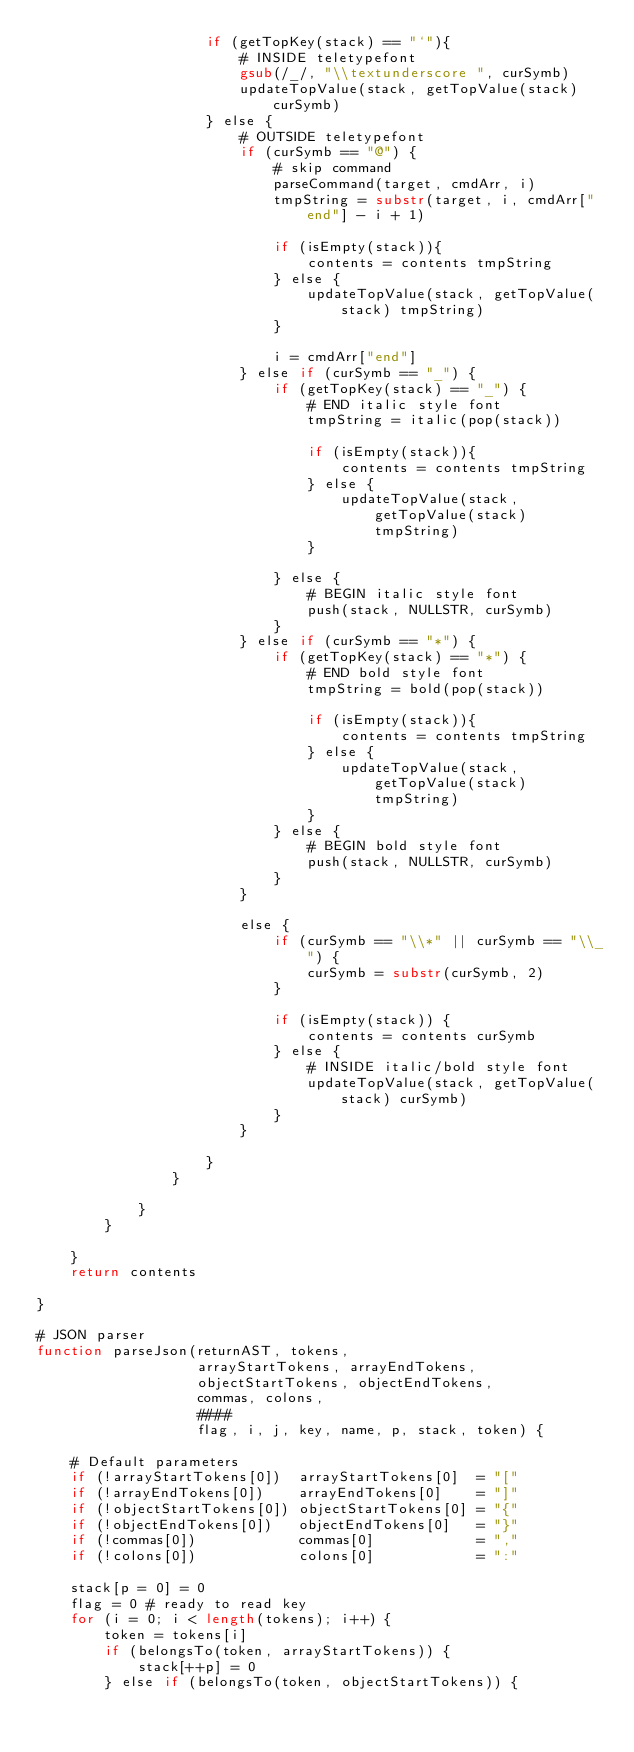Convert code to text. <code><loc_0><loc_0><loc_500><loc_500><_Awk_>                    if (getTopKey(stack) == "`"){
                        # INSIDE teletypefont
                        gsub(/_/, "\\textunderscore ", curSymb)
                        updateTopValue(stack, getTopValue(stack) curSymb)
                    } else {
                        # OUTSIDE teletypefont
                        if (curSymb == "@") {
                            # skip command
                            parseCommand(target, cmdArr, i)
                            tmpString = substr(target, i, cmdArr["end"] - i + 1)

                            if (isEmpty(stack)){
                                contents = contents tmpString
                            } else {
                                updateTopValue(stack, getTopValue(stack) tmpString)
                            }
                            
                            i = cmdArr["end"]
                        } else if (curSymb == "_") {
                            if (getTopKey(stack) == "_") {
                                # END italic style font
                                tmpString = italic(pop(stack))

                                if (isEmpty(stack)){
                                    contents = contents tmpString
                                } else {
                                    updateTopValue(stack, getTopValue(stack) tmpString)
                                }

                            } else {
                                # BEGIN italic style font
                                push(stack, NULLSTR, curSymb)
                            }
                        } else if (curSymb == "*") {
                            if (getTopKey(stack) == "*") {
                                # END bold style font
                                tmpString = bold(pop(stack))

                                if (isEmpty(stack)){
                                    contents = contents tmpString
                                } else {
                                    updateTopValue(stack, getTopValue(stack) tmpString)
                                }
                            } else {
                                # BEGIN bold style font
                                push(stack, NULLSTR, curSymb)
                            }
                        }

                        else {
                            if (curSymb == "\\*" || curSymb == "\\_") {
                                curSymb = substr(curSymb, 2)
                            }

                            if (isEmpty(stack)) {
                                contents = contents curSymb
                            } else {
                                # INSIDE italic/bold style font
                                updateTopValue(stack, getTopValue(stack) curSymb)
                            }
                        }

                    }
                }

            }
        }

    }
    return contents
        
}

# JSON parser
function parseJson(returnAST, tokens,
                   arrayStartTokens, arrayEndTokens,
                   objectStartTokens, objectEndTokens,
                   commas, colons,
                   ####
                   flag, i, j, key, name, p, stack, token) {

    # Default parameters
    if (!arrayStartTokens[0])  arrayStartTokens[0]  = "["
    if (!arrayEndTokens[0])    arrayEndTokens[0]    = "]"
    if (!objectStartTokens[0]) objectStartTokens[0] = "{"
    if (!objectEndTokens[0])   objectEndTokens[0]   = "}"
    if (!commas[0])            commas[0]            = ","
    if (!colons[0])            colons[0]            = ":"

    stack[p = 0] = 0
    flag = 0 # ready to read key
    for (i = 0; i < length(tokens); i++) {
        token = tokens[i]
        if (belongsTo(token, arrayStartTokens)) {
            stack[++p] = 0
        } else if (belongsTo(token, objectStartTokens)) {</code> 